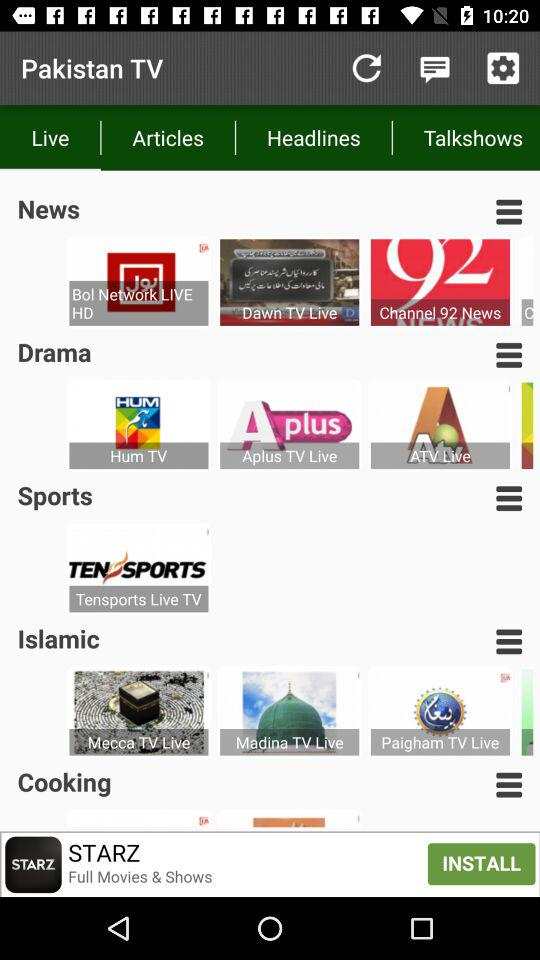How many more items are in the Islamic category than the Sports category?
Answer the question using a single word or phrase. 2 